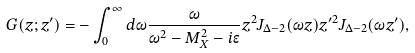Convert formula to latex. <formula><loc_0><loc_0><loc_500><loc_500>G ( z ; z ^ { \prime } ) = - \int _ { 0 } ^ { \infty } d \omega \frac { \omega } { \omega ^ { 2 } - M _ { X } ^ { 2 } - i \epsilon } z ^ { 2 } J _ { \Delta - 2 } ( \omega z ) z ^ { \prime 2 } J _ { \Delta - 2 } ( \omega z ^ { \prime } ) ,</formula> 